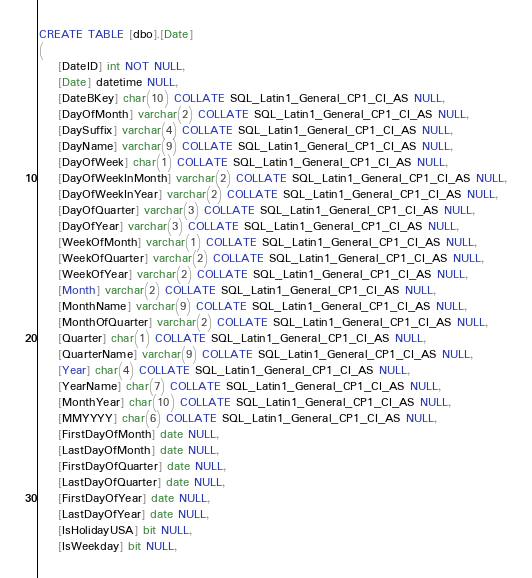<code> <loc_0><loc_0><loc_500><loc_500><_SQL_>CREATE TABLE [dbo].[Date]
(
	[DateID] int NOT NULL,
	[Date] datetime NULL,
	[DateBKey] char(10) COLLATE SQL_Latin1_General_CP1_CI_AS NULL,
	[DayOfMonth] varchar(2) COLLATE SQL_Latin1_General_CP1_CI_AS NULL,
	[DaySuffix] varchar(4) COLLATE SQL_Latin1_General_CP1_CI_AS NULL,
	[DayName] varchar(9) COLLATE SQL_Latin1_General_CP1_CI_AS NULL,
	[DayOfWeek] char(1) COLLATE SQL_Latin1_General_CP1_CI_AS NULL,
	[DayOfWeekInMonth] varchar(2) COLLATE SQL_Latin1_General_CP1_CI_AS NULL,
	[DayOfWeekInYear] varchar(2) COLLATE SQL_Latin1_General_CP1_CI_AS NULL,
	[DayOfQuarter] varchar(3) COLLATE SQL_Latin1_General_CP1_CI_AS NULL,
	[DayOfYear] varchar(3) COLLATE SQL_Latin1_General_CP1_CI_AS NULL,
	[WeekOfMonth] varchar(1) COLLATE SQL_Latin1_General_CP1_CI_AS NULL,
	[WeekOfQuarter] varchar(2) COLLATE SQL_Latin1_General_CP1_CI_AS NULL,
	[WeekOfYear] varchar(2) COLLATE SQL_Latin1_General_CP1_CI_AS NULL,
	[Month] varchar(2) COLLATE SQL_Latin1_General_CP1_CI_AS NULL,
	[MonthName] varchar(9) COLLATE SQL_Latin1_General_CP1_CI_AS NULL,
	[MonthOfQuarter] varchar(2) COLLATE SQL_Latin1_General_CP1_CI_AS NULL,
	[Quarter] char(1) COLLATE SQL_Latin1_General_CP1_CI_AS NULL,
	[QuarterName] varchar(9) COLLATE SQL_Latin1_General_CP1_CI_AS NULL,
	[Year] char(4) COLLATE SQL_Latin1_General_CP1_CI_AS NULL,
	[YearName] char(7) COLLATE SQL_Latin1_General_CP1_CI_AS NULL,
	[MonthYear] char(10) COLLATE SQL_Latin1_General_CP1_CI_AS NULL,
	[MMYYYY] char(6) COLLATE SQL_Latin1_General_CP1_CI_AS NULL,
	[FirstDayOfMonth] date NULL,
	[LastDayOfMonth] date NULL,
	[FirstDayOfQuarter] date NULL,
	[LastDayOfQuarter] date NULL,
	[FirstDayOfYear] date NULL,
	[LastDayOfYear] date NULL,
	[IsHolidayUSA] bit NULL,
	[IsWeekday] bit NULL,</code> 